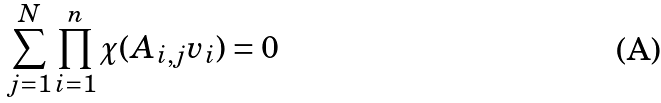Convert formula to latex. <formula><loc_0><loc_0><loc_500><loc_500>\sum _ { j = 1 } ^ { N } \prod _ { i = 1 } ^ { n } \chi ( A _ { i , j } v _ { i } ) = 0</formula> 